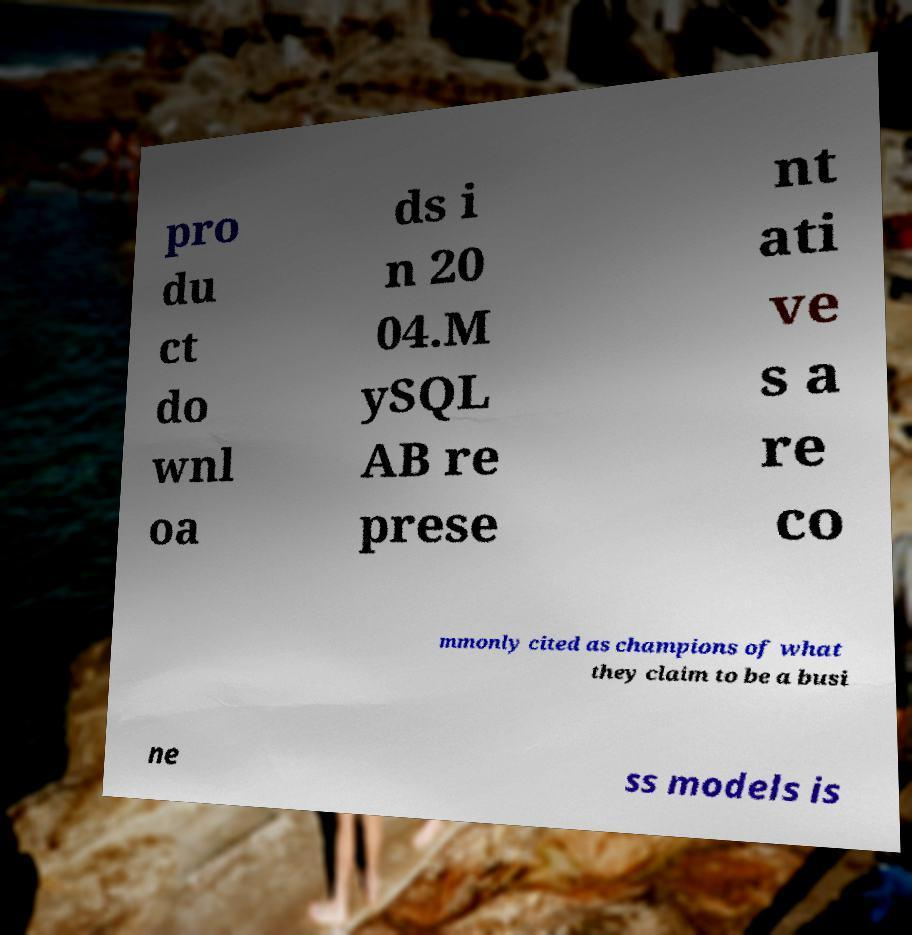There's text embedded in this image that I need extracted. Can you transcribe it verbatim? pro du ct do wnl oa ds i n 20 04.M ySQL AB re prese nt ati ve s a re co mmonly cited as champions of what they claim to be a busi ne ss models is 